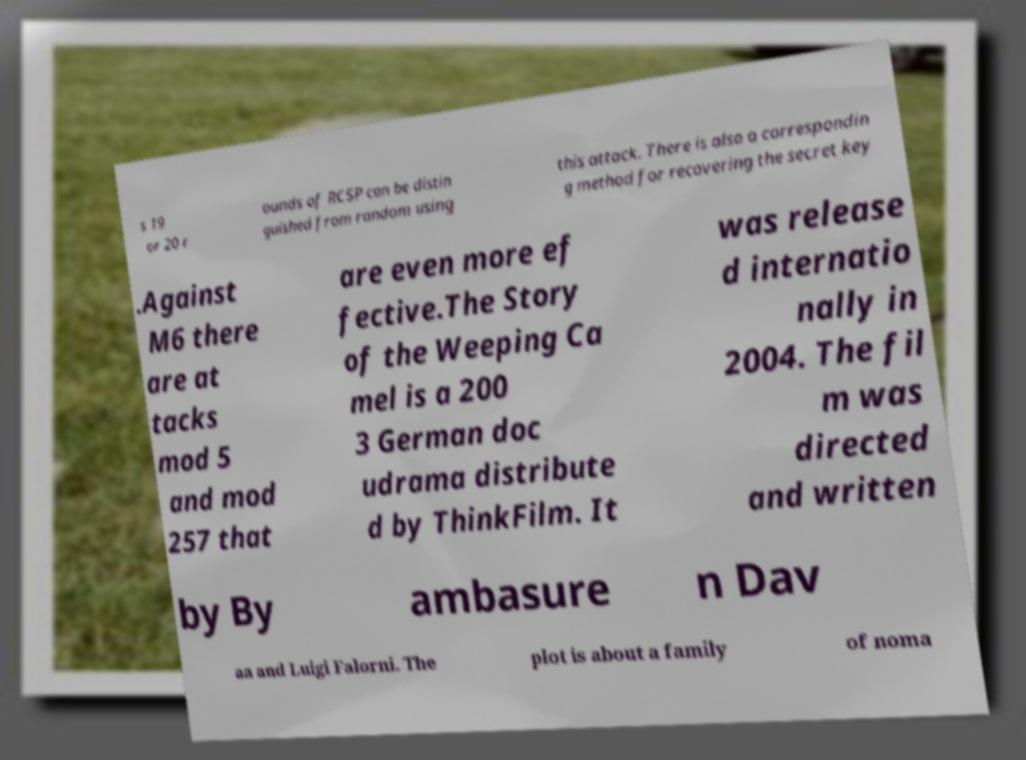There's text embedded in this image that I need extracted. Can you transcribe it verbatim? s 19 or 20 r ounds of RC5P can be distin guished from random using this attack. There is also a correspondin g method for recovering the secret key .Against M6 there are at tacks mod 5 and mod 257 that are even more ef fective.The Story of the Weeping Ca mel is a 200 3 German doc udrama distribute d by ThinkFilm. It was release d internatio nally in 2004. The fil m was directed and written by By ambasure n Dav aa and Luigi Falorni. The plot is about a family of noma 